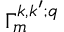<formula> <loc_0><loc_0><loc_500><loc_500>\Gamma _ { m } ^ { k , k ^ { \prime } ; q }</formula> 